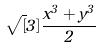<formula> <loc_0><loc_0><loc_500><loc_500>\sqrt { [ } 3 ] { \frac { x ^ { 3 } + y ^ { 3 } } { 2 } }</formula> 